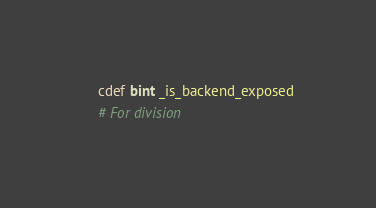Convert code to text. <code><loc_0><loc_0><loc_500><loc_500><_Cython_>    cdef bint _is_backend_exposed
    # For division</code> 